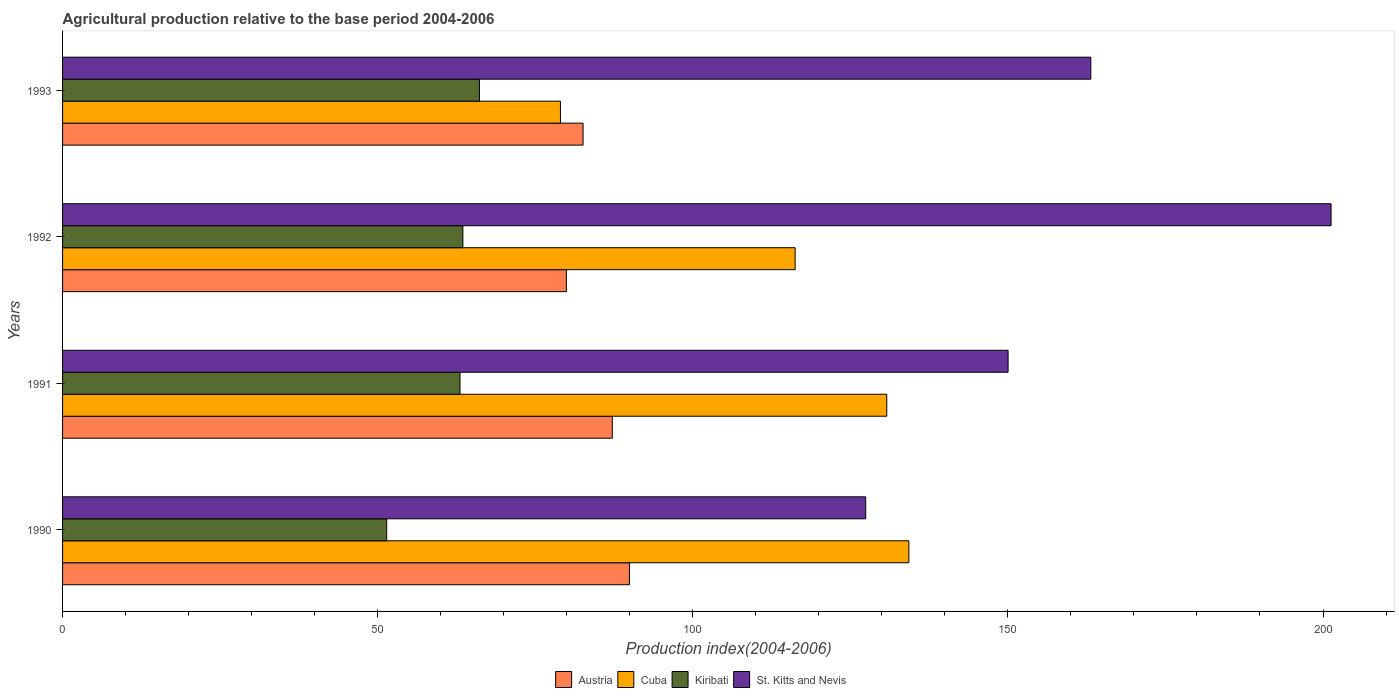How many groups of bars are there?
Give a very brief answer. 4. How many bars are there on the 4th tick from the top?
Your answer should be compact. 4. What is the label of the 4th group of bars from the top?
Your answer should be compact. 1990. What is the agricultural production index in Cuba in 1992?
Offer a terse response. 116.24. Across all years, what is the maximum agricultural production index in St. Kitts and Nevis?
Your response must be concise. 201.28. Across all years, what is the minimum agricultural production index in Cuba?
Give a very brief answer. 79. In which year was the agricultural production index in Austria minimum?
Offer a very short reply. 1992. What is the total agricultural production index in St. Kitts and Nevis in the graph?
Offer a very short reply. 641.91. What is the difference between the agricultural production index in Cuba in 1992 and that in 1993?
Your answer should be very brief. 37.24. What is the difference between the agricultural production index in St. Kitts and Nevis in 1990 and the agricultural production index in Kiribati in 1992?
Offer a very short reply. 63.92. What is the average agricultural production index in Cuba per year?
Offer a very short reply. 115.08. In the year 1992, what is the difference between the agricultural production index in St. Kitts and Nevis and agricultural production index in Cuba?
Provide a short and direct response. 85.04. What is the ratio of the agricultural production index in Cuba in 1992 to that in 1993?
Give a very brief answer. 1.47. What is the difference between the highest and the second highest agricultural production index in Austria?
Ensure brevity in your answer.  2.72. What is the difference between the highest and the lowest agricultural production index in Kiribati?
Your answer should be compact. 14.72. Is it the case that in every year, the sum of the agricultural production index in St. Kitts and Nevis and agricultural production index in Kiribati is greater than the sum of agricultural production index in Austria and agricultural production index in Cuba?
Provide a succinct answer. No. What does the 2nd bar from the top in 1992 represents?
Offer a terse response. Kiribati. How many bars are there?
Keep it short and to the point. 16. Are all the bars in the graph horizontal?
Ensure brevity in your answer.  Yes. How many years are there in the graph?
Make the answer very short. 4. Are the values on the major ticks of X-axis written in scientific E-notation?
Provide a short and direct response. No. Does the graph contain grids?
Offer a very short reply. No. How many legend labels are there?
Give a very brief answer. 4. How are the legend labels stacked?
Give a very brief answer. Horizontal. What is the title of the graph?
Give a very brief answer. Agricultural production relative to the base period 2004-2006. What is the label or title of the X-axis?
Give a very brief answer. Production index(2004-2006). What is the Production index(2004-2006) in Austria in 1990?
Provide a short and direct response. 89.95. What is the Production index(2004-2006) of Cuba in 1990?
Ensure brevity in your answer.  134.29. What is the Production index(2004-2006) in Kiribati in 1990?
Give a very brief answer. 51.43. What is the Production index(2004-2006) of St. Kitts and Nevis in 1990?
Your answer should be compact. 127.44. What is the Production index(2004-2006) in Austria in 1991?
Offer a terse response. 87.23. What is the Production index(2004-2006) in Cuba in 1991?
Offer a terse response. 130.78. What is the Production index(2004-2006) of Kiribati in 1991?
Offer a very short reply. 63.06. What is the Production index(2004-2006) in St. Kitts and Nevis in 1991?
Give a very brief answer. 150.03. What is the Production index(2004-2006) of Austria in 1992?
Offer a very short reply. 79.94. What is the Production index(2004-2006) in Cuba in 1992?
Keep it short and to the point. 116.24. What is the Production index(2004-2006) of Kiribati in 1992?
Provide a short and direct response. 63.52. What is the Production index(2004-2006) in St. Kitts and Nevis in 1992?
Your answer should be compact. 201.28. What is the Production index(2004-2006) of Austria in 1993?
Ensure brevity in your answer.  82.59. What is the Production index(2004-2006) of Cuba in 1993?
Provide a succinct answer. 79. What is the Production index(2004-2006) in Kiribati in 1993?
Provide a short and direct response. 66.15. What is the Production index(2004-2006) in St. Kitts and Nevis in 1993?
Your answer should be very brief. 163.16. Across all years, what is the maximum Production index(2004-2006) of Austria?
Ensure brevity in your answer.  89.95. Across all years, what is the maximum Production index(2004-2006) in Cuba?
Make the answer very short. 134.29. Across all years, what is the maximum Production index(2004-2006) in Kiribati?
Ensure brevity in your answer.  66.15. Across all years, what is the maximum Production index(2004-2006) in St. Kitts and Nevis?
Offer a terse response. 201.28. Across all years, what is the minimum Production index(2004-2006) in Austria?
Your answer should be compact. 79.94. Across all years, what is the minimum Production index(2004-2006) in Cuba?
Your answer should be very brief. 79. Across all years, what is the minimum Production index(2004-2006) of Kiribati?
Provide a short and direct response. 51.43. Across all years, what is the minimum Production index(2004-2006) of St. Kitts and Nevis?
Keep it short and to the point. 127.44. What is the total Production index(2004-2006) in Austria in the graph?
Your answer should be very brief. 339.71. What is the total Production index(2004-2006) of Cuba in the graph?
Ensure brevity in your answer.  460.31. What is the total Production index(2004-2006) in Kiribati in the graph?
Your answer should be compact. 244.16. What is the total Production index(2004-2006) in St. Kitts and Nevis in the graph?
Your response must be concise. 641.91. What is the difference between the Production index(2004-2006) in Austria in 1990 and that in 1991?
Ensure brevity in your answer.  2.72. What is the difference between the Production index(2004-2006) in Cuba in 1990 and that in 1991?
Your response must be concise. 3.51. What is the difference between the Production index(2004-2006) of Kiribati in 1990 and that in 1991?
Keep it short and to the point. -11.63. What is the difference between the Production index(2004-2006) in St. Kitts and Nevis in 1990 and that in 1991?
Ensure brevity in your answer.  -22.59. What is the difference between the Production index(2004-2006) of Austria in 1990 and that in 1992?
Offer a very short reply. 10.01. What is the difference between the Production index(2004-2006) in Cuba in 1990 and that in 1992?
Provide a short and direct response. 18.05. What is the difference between the Production index(2004-2006) in Kiribati in 1990 and that in 1992?
Your response must be concise. -12.09. What is the difference between the Production index(2004-2006) of St. Kitts and Nevis in 1990 and that in 1992?
Your answer should be very brief. -73.84. What is the difference between the Production index(2004-2006) of Austria in 1990 and that in 1993?
Provide a short and direct response. 7.36. What is the difference between the Production index(2004-2006) of Cuba in 1990 and that in 1993?
Give a very brief answer. 55.29. What is the difference between the Production index(2004-2006) in Kiribati in 1990 and that in 1993?
Keep it short and to the point. -14.72. What is the difference between the Production index(2004-2006) in St. Kitts and Nevis in 1990 and that in 1993?
Your answer should be very brief. -35.72. What is the difference between the Production index(2004-2006) of Austria in 1991 and that in 1992?
Your answer should be very brief. 7.29. What is the difference between the Production index(2004-2006) in Cuba in 1991 and that in 1992?
Offer a very short reply. 14.54. What is the difference between the Production index(2004-2006) in Kiribati in 1991 and that in 1992?
Your answer should be compact. -0.46. What is the difference between the Production index(2004-2006) of St. Kitts and Nevis in 1991 and that in 1992?
Ensure brevity in your answer.  -51.25. What is the difference between the Production index(2004-2006) of Austria in 1991 and that in 1993?
Your answer should be very brief. 4.64. What is the difference between the Production index(2004-2006) of Cuba in 1991 and that in 1993?
Your answer should be very brief. 51.78. What is the difference between the Production index(2004-2006) in Kiribati in 1991 and that in 1993?
Provide a succinct answer. -3.09. What is the difference between the Production index(2004-2006) of St. Kitts and Nevis in 1991 and that in 1993?
Make the answer very short. -13.13. What is the difference between the Production index(2004-2006) of Austria in 1992 and that in 1993?
Offer a terse response. -2.65. What is the difference between the Production index(2004-2006) in Cuba in 1992 and that in 1993?
Your response must be concise. 37.24. What is the difference between the Production index(2004-2006) in Kiribati in 1992 and that in 1993?
Your answer should be very brief. -2.63. What is the difference between the Production index(2004-2006) in St. Kitts and Nevis in 1992 and that in 1993?
Your response must be concise. 38.12. What is the difference between the Production index(2004-2006) of Austria in 1990 and the Production index(2004-2006) of Cuba in 1991?
Your answer should be very brief. -40.83. What is the difference between the Production index(2004-2006) of Austria in 1990 and the Production index(2004-2006) of Kiribati in 1991?
Your answer should be very brief. 26.89. What is the difference between the Production index(2004-2006) of Austria in 1990 and the Production index(2004-2006) of St. Kitts and Nevis in 1991?
Keep it short and to the point. -60.08. What is the difference between the Production index(2004-2006) in Cuba in 1990 and the Production index(2004-2006) in Kiribati in 1991?
Your answer should be compact. 71.23. What is the difference between the Production index(2004-2006) of Cuba in 1990 and the Production index(2004-2006) of St. Kitts and Nevis in 1991?
Ensure brevity in your answer.  -15.74. What is the difference between the Production index(2004-2006) in Kiribati in 1990 and the Production index(2004-2006) in St. Kitts and Nevis in 1991?
Your answer should be compact. -98.6. What is the difference between the Production index(2004-2006) in Austria in 1990 and the Production index(2004-2006) in Cuba in 1992?
Offer a very short reply. -26.29. What is the difference between the Production index(2004-2006) in Austria in 1990 and the Production index(2004-2006) in Kiribati in 1992?
Provide a succinct answer. 26.43. What is the difference between the Production index(2004-2006) in Austria in 1990 and the Production index(2004-2006) in St. Kitts and Nevis in 1992?
Your response must be concise. -111.33. What is the difference between the Production index(2004-2006) of Cuba in 1990 and the Production index(2004-2006) of Kiribati in 1992?
Give a very brief answer. 70.77. What is the difference between the Production index(2004-2006) of Cuba in 1990 and the Production index(2004-2006) of St. Kitts and Nevis in 1992?
Give a very brief answer. -66.99. What is the difference between the Production index(2004-2006) of Kiribati in 1990 and the Production index(2004-2006) of St. Kitts and Nevis in 1992?
Your answer should be very brief. -149.85. What is the difference between the Production index(2004-2006) of Austria in 1990 and the Production index(2004-2006) of Cuba in 1993?
Offer a terse response. 10.95. What is the difference between the Production index(2004-2006) of Austria in 1990 and the Production index(2004-2006) of Kiribati in 1993?
Offer a terse response. 23.8. What is the difference between the Production index(2004-2006) of Austria in 1990 and the Production index(2004-2006) of St. Kitts and Nevis in 1993?
Your response must be concise. -73.21. What is the difference between the Production index(2004-2006) in Cuba in 1990 and the Production index(2004-2006) in Kiribati in 1993?
Provide a succinct answer. 68.14. What is the difference between the Production index(2004-2006) in Cuba in 1990 and the Production index(2004-2006) in St. Kitts and Nevis in 1993?
Provide a succinct answer. -28.87. What is the difference between the Production index(2004-2006) in Kiribati in 1990 and the Production index(2004-2006) in St. Kitts and Nevis in 1993?
Offer a very short reply. -111.73. What is the difference between the Production index(2004-2006) in Austria in 1991 and the Production index(2004-2006) in Cuba in 1992?
Ensure brevity in your answer.  -29.01. What is the difference between the Production index(2004-2006) of Austria in 1991 and the Production index(2004-2006) of Kiribati in 1992?
Your response must be concise. 23.71. What is the difference between the Production index(2004-2006) in Austria in 1991 and the Production index(2004-2006) in St. Kitts and Nevis in 1992?
Your response must be concise. -114.05. What is the difference between the Production index(2004-2006) of Cuba in 1991 and the Production index(2004-2006) of Kiribati in 1992?
Keep it short and to the point. 67.26. What is the difference between the Production index(2004-2006) in Cuba in 1991 and the Production index(2004-2006) in St. Kitts and Nevis in 1992?
Your answer should be very brief. -70.5. What is the difference between the Production index(2004-2006) in Kiribati in 1991 and the Production index(2004-2006) in St. Kitts and Nevis in 1992?
Provide a succinct answer. -138.22. What is the difference between the Production index(2004-2006) of Austria in 1991 and the Production index(2004-2006) of Cuba in 1993?
Provide a succinct answer. 8.23. What is the difference between the Production index(2004-2006) of Austria in 1991 and the Production index(2004-2006) of Kiribati in 1993?
Provide a succinct answer. 21.08. What is the difference between the Production index(2004-2006) of Austria in 1991 and the Production index(2004-2006) of St. Kitts and Nevis in 1993?
Provide a short and direct response. -75.93. What is the difference between the Production index(2004-2006) in Cuba in 1991 and the Production index(2004-2006) in Kiribati in 1993?
Keep it short and to the point. 64.63. What is the difference between the Production index(2004-2006) of Cuba in 1991 and the Production index(2004-2006) of St. Kitts and Nevis in 1993?
Give a very brief answer. -32.38. What is the difference between the Production index(2004-2006) in Kiribati in 1991 and the Production index(2004-2006) in St. Kitts and Nevis in 1993?
Your answer should be very brief. -100.1. What is the difference between the Production index(2004-2006) in Austria in 1992 and the Production index(2004-2006) in Kiribati in 1993?
Your answer should be very brief. 13.79. What is the difference between the Production index(2004-2006) in Austria in 1992 and the Production index(2004-2006) in St. Kitts and Nevis in 1993?
Provide a succinct answer. -83.22. What is the difference between the Production index(2004-2006) of Cuba in 1992 and the Production index(2004-2006) of Kiribati in 1993?
Make the answer very short. 50.09. What is the difference between the Production index(2004-2006) in Cuba in 1992 and the Production index(2004-2006) in St. Kitts and Nevis in 1993?
Offer a terse response. -46.92. What is the difference between the Production index(2004-2006) in Kiribati in 1992 and the Production index(2004-2006) in St. Kitts and Nevis in 1993?
Your response must be concise. -99.64. What is the average Production index(2004-2006) in Austria per year?
Ensure brevity in your answer.  84.93. What is the average Production index(2004-2006) of Cuba per year?
Give a very brief answer. 115.08. What is the average Production index(2004-2006) of Kiribati per year?
Provide a succinct answer. 61.04. What is the average Production index(2004-2006) in St. Kitts and Nevis per year?
Provide a short and direct response. 160.48. In the year 1990, what is the difference between the Production index(2004-2006) of Austria and Production index(2004-2006) of Cuba?
Your answer should be very brief. -44.34. In the year 1990, what is the difference between the Production index(2004-2006) of Austria and Production index(2004-2006) of Kiribati?
Your answer should be compact. 38.52. In the year 1990, what is the difference between the Production index(2004-2006) in Austria and Production index(2004-2006) in St. Kitts and Nevis?
Provide a short and direct response. -37.49. In the year 1990, what is the difference between the Production index(2004-2006) in Cuba and Production index(2004-2006) in Kiribati?
Your answer should be compact. 82.86. In the year 1990, what is the difference between the Production index(2004-2006) of Cuba and Production index(2004-2006) of St. Kitts and Nevis?
Ensure brevity in your answer.  6.85. In the year 1990, what is the difference between the Production index(2004-2006) of Kiribati and Production index(2004-2006) of St. Kitts and Nevis?
Your response must be concise. -76.01. In the year 1991, what is the difference between the Production index(2004-2006) of Austria and Production index(2004-2006) of Cuba?
Your response must be concise. -43.55. In the year 1991, what is the difference between the Production index(2004-2006) of Austria and Production index(2004-2006) of Kiribati?
Your answer should be compact. 24.17. In the year 1991, what is the difference between the Production index(2004-2006) of Austria and Production index(2004-2006) of St. Kitts and Nevis?
Provide a succinct answer. -62.8. In the year 1991, what is the difference between the Production index(2004-2006) in Cuba and Production index(2004-2006) in Kiribati?
Your answer should be very brief. 67.72. In the year 1991, what is the difference between the Production index(2004-2006) of Cuba and Production index(2004-2006) of St. Kitts and Nevis?
Your response must be concise. -19.25. In the year 1991, what is the difference between the Production index(2004-2006) of Kiribati and Production index(2004-2006) of St. Kitts and Nevis?
Keep it short and to the point. -86.97. In the year 1992, what is the difference between the Production index(2004-2006) in Austria and Production index(2004-2006) in Cuba?
Your answer should be very brief. -36.3. In the year 1992, what is the difference between the Production index(2004-2006) in Austria and Production index(2004-2006) in Kiribati?
Offer a very short reply. 16.42. In the year 1992, what is the difference between the Production index(2004-2006) of Austria and Production index(2004-2006) of St. Kitts and Nevis?
Your answer should be very brief. -121.34. In the year 1992, what is the difference between the Production index(2004-2006) of Cuba and Production index(2004-2006) of Kiribati?
Your response must be concise. 52.72. In the year 1992, what is the difference between the Production index(2004-2006) in Cuba and Production index(2004-2006) in St. Kitts and Nevis?
Your response must be concise. -85.04. In the year 1992, what is the difference between the Production index(2004-2006) in Kiribati and Production index(2004-2006) in St. Kitts and Nevis?
Your answer should be compact. -137.76. In the year 1993, what is the difference between the Production index(2004-2006) in Austria and Production index(2004-2006) in Cuba?
Ensure brevity in your answer.  3.59. In the year 1993, what is the difference between the Production index(2004-2006) in Austria and Production index(2004-2006) in Kiribati?
Give a very brief answer. 16.44. In the year 1993, what is the difference between the Production index(2004-2006) of Austria and Production index(2004-2006) of St. Kitts and Nevis?
Give a very brief answer. -80.57. In the year 1993, what is the difference between the Production index(2004-2006) in Cuba and Production index(2004-2006) in Kiribati?
Ensure brevity in your answer.  12.85. In the year 1993, what is the difference between the Production index(2004-2006) of Cuba and Production index(2004-2006) of St. Kitts and Nevis?
Provide a succinct answer. -84.16. In the year 1993, what is the difference between the Production index(2004-2006) of Kiribati and Production index(2004-2006) of St. Kitts and Nevis?
Keep it short and to the point. -97.01. What is the ratio of the Production index(2004-2006) in Austria in 1990 to that in 1991?
Your response must be concise. 1.03. What is the ratio of the Production index(2004-2006) in Cuba in 1990 to that in 1991?
Your answer should be very brief. 1.03. What is the ratio of the Production index(2004-2006) of Kiribati in 1990 to that in 1991?
Your answer should be compact. 0.82. What is the ratio of the Production index(2004-2006) in St. Kitts and Nevis in 1990 to that in 1991?
Make the answer very short. 0.85. What is the ratio of the Production index(2004-2006) in Austria in 1990 to that in 1992?
Provide a succinct answer. 1.13. What is the ratio of the Production index(2004-2006) of Cuba in 1990 to that in 1992?
Provide a short and direct response. 1.16. What is the ratio of the Production index(2004-2006) of Kiribati in 1990 to that in 1992?
Your answer should be very brief. 0.81. What is the ratio of the Production index(2004-2006) of St. Kitts and Nevis in 1990 to that in 1992?
Offer a very short reply. 0.63. What is the ratio of the Production index(2004-2006) of Austria in 1990 to that in 1993?
Offer a very short reply. 1.09. What is the ratio of the Production index(2004-2006) of Cuba in 1990 to that in 1993?
Provide a short and direct response. 1.7. What is the ratio of the Production index(2004-2006) in Kiribati in 1990 to that in 1993?
Keep it short and to the point. 0.78. What is the ratio of the Production index(2004-2006) in St. Kitts and Nevis in 1990 to that in 1993?
Make the answer very short. 0.78. What is the ratio of the Production index(2004-2006) of Austria in 1991 to that in 1992?
Ensure brevity in your answer.  1.09. What is the ratio of the Production index(2004-2006) in Cuba in 1991 to that in 1992?
Your answer should be very brief. 1.13. What is the ratio of the Production index(2004-2006) in St. Kitts and Nevis in 1991 to that in 1992?
Ensure brevity in your answer.  0.75. What is the ratio of the Production index(2004-2006) of Austria in 1991 to that in 1993?
Make the answer very short. 1.06. What is the ratio of the Production index(2004-2006) in Cuba in 1991 to that in 1993?
Your answer should be compact. 1.66. What is the ratio of the Production index(2004-2006) in Kiribati in 1991 to that in 1993?
Offer a terse response. 0.95. What is the ratio of the Production index(2004-2006) of St. Kitts and Nevis in 1991 to that in 1993?
Provide a succinct answer. 0.92. What is the ratio of the Production index(2004-2006) in Austria in 1992 to that in 1993?
Provide a short and direct response. 0.97. What is the ratio of the Production index(2004-2006) of Cuba in 1992 to that in 1993?
Provide a succinct answer. 1.47. What is the ratio of the Production index(2004-2006) of Kiribati in 1992 to that in 1993?
Your answer should be very brief. 0.96. What is the ratio of the Production index(2004-2006) of St. Kitts and Nevis in 1992 to that in 1993?
Make the answer very short. 1.23. What is the difference between the highest and the second highest Production index(2004-2006) of Austria?
Keep it short and to the point. 2.72. What is the difference between the highest and the second highest Production index(2004-2006) of Cuba?
Provide a succinct answer. 3.51. What is the difference between the highest and the second highest Production index(2004-2006) of Kiribati?
Make the answer very short. 2.63. What is the difference between the highest and the second highest Production index(2004-2006) in St. Kitts and Nevis?
Your answer should be compact. 38.12. What is the difference between the highest and the lowest Production index(2004-2006) of Austria?
Give a very brief answer. 10.01. What is the difference between the highest and the lowest Production index(2004-2006) of Cuba?
Keep it short and to the point. 55.29. What is the difference between the highest and the lowest Production index(2004-2006) in Kiribati?
Keep it short and to the point. 14.72. What is the difference between the highest and the lowest Production index(2004-2006) in St. Kitts and Nevis?
Provide a short and direct response. 73.84. 